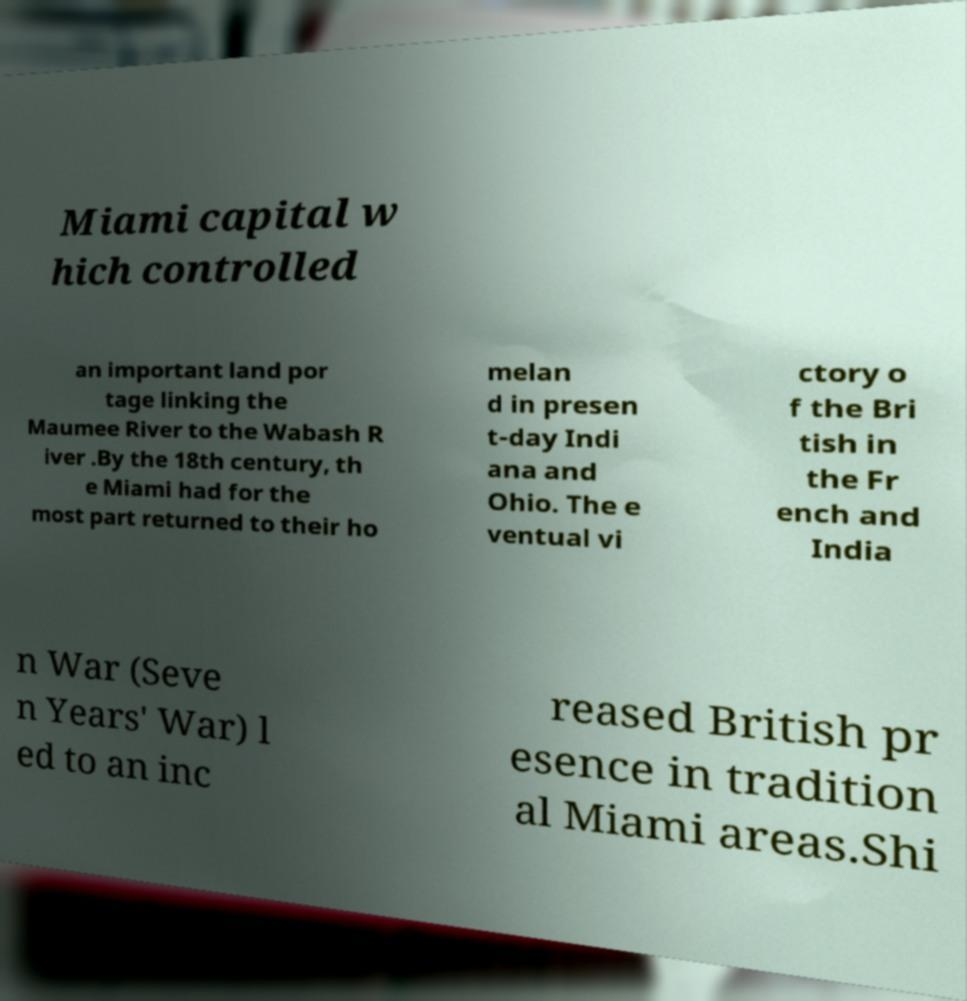Can you read and provide the text displayed in the image?This photo seems to have some interesting text. Can you extract and type it out for me? Miami capital w hich controlled an important land por tage linking the Maumee River to the Wabash R iver .By the 18th century, th e Miami had for the most part returned to their ho melan d in presen t-day Indi ana and Ohio. The e ventual vi ctory o f the Bri tish in the Fr ench and India n War (Seve n Years' War) l ed to an inc reased British pr esence in tradition al Miami areas.Shi 